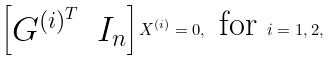<formula> <loc_0><loc_0><loc_500><loc_500>\begin{bmatrix} G ^ { ( i ) ^ { T } } & I _ { n } \end{bmatrix} X ^ { ( i ) } = 0 , \text { for } i = 1 , 2 ,</formula> 